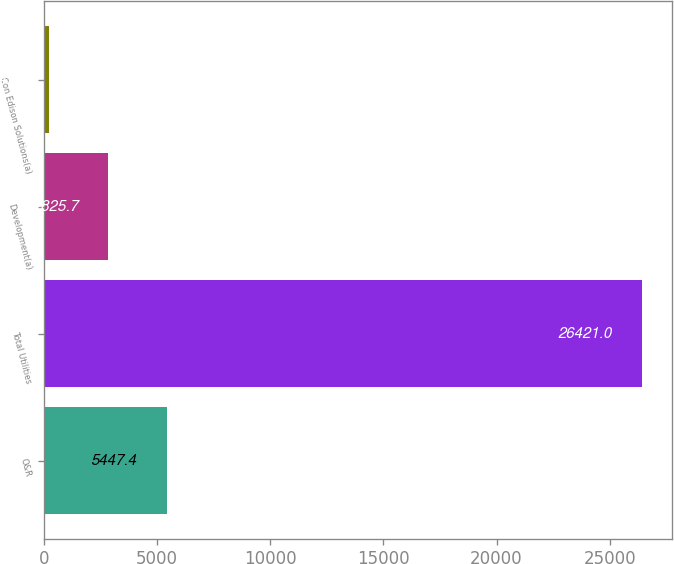Convert chart to OTSL. <chart><loc_0><loc_0><loc_500><loc_500><bar_chart><fcel>O&R<fcel>Total Utilities<fcel>Development(a)<fcel>Con Edison Solutions(a)<nl><fcel>5447.4<fcel>26421<fcel>2825.7<fcel>204<nl></chart> 